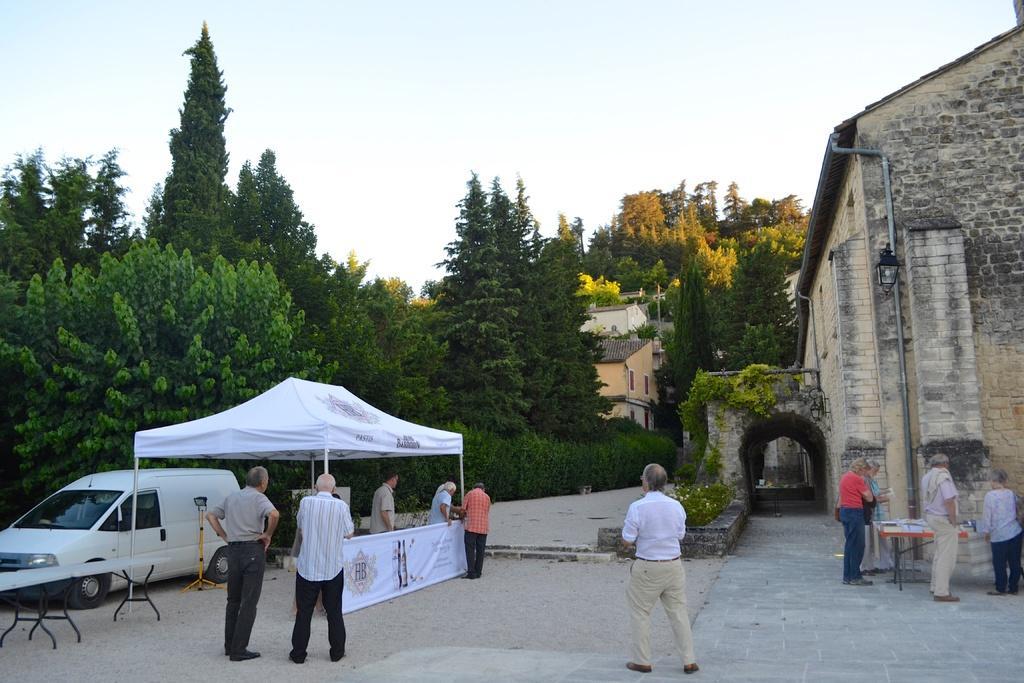In one or two sentences, can you explain what this image depicts? In this picture we can see few trees, buildings and group of people, and also we can see a car and a tent on the left side of the image, in the background we can see a pipe on the wall. 